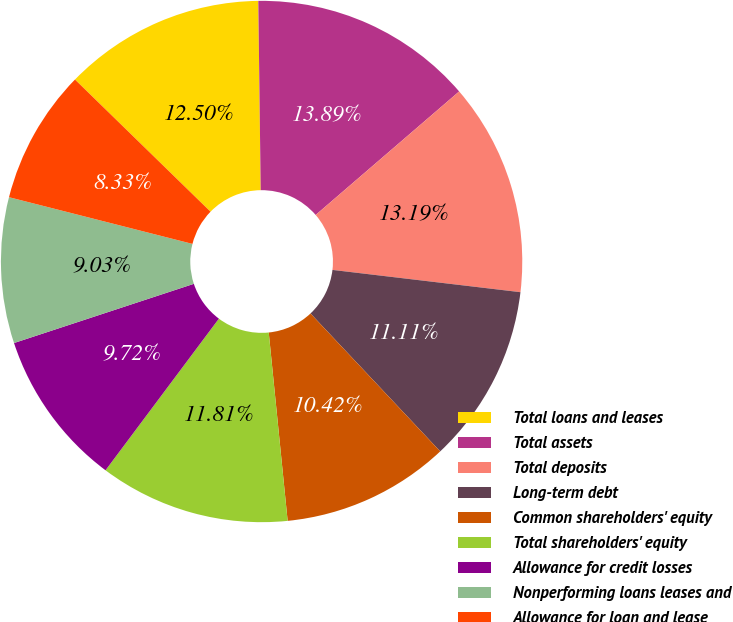<chart> <loc_0><loc_0><loc_500><loc_500><pie_chart><fcel>Total loans and leases<fcel>Total assets<fcel>Total deposits<fcel>Long-term debt<fcel>Common shareholders' equity<fcel>Total shareholders' equity<fcel>Allowance for credit losses<fcel>Nonperforming loans leases and<fcel>Allowance for loan and lease<nl><fcel>12.5%<fcel>13.89%<fcel>13.19%<fcel>11.11%<fcel>10.42%<fcel>11.81%<fcel>9.72%<fcel>9.03%<fcel>8.33%<nl></chart> 